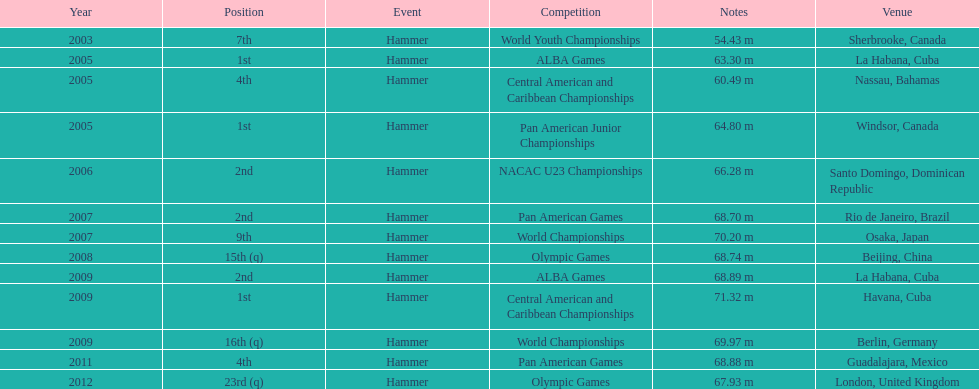In which olympic games did arasay thondike not finish in the top 20? 2012. 